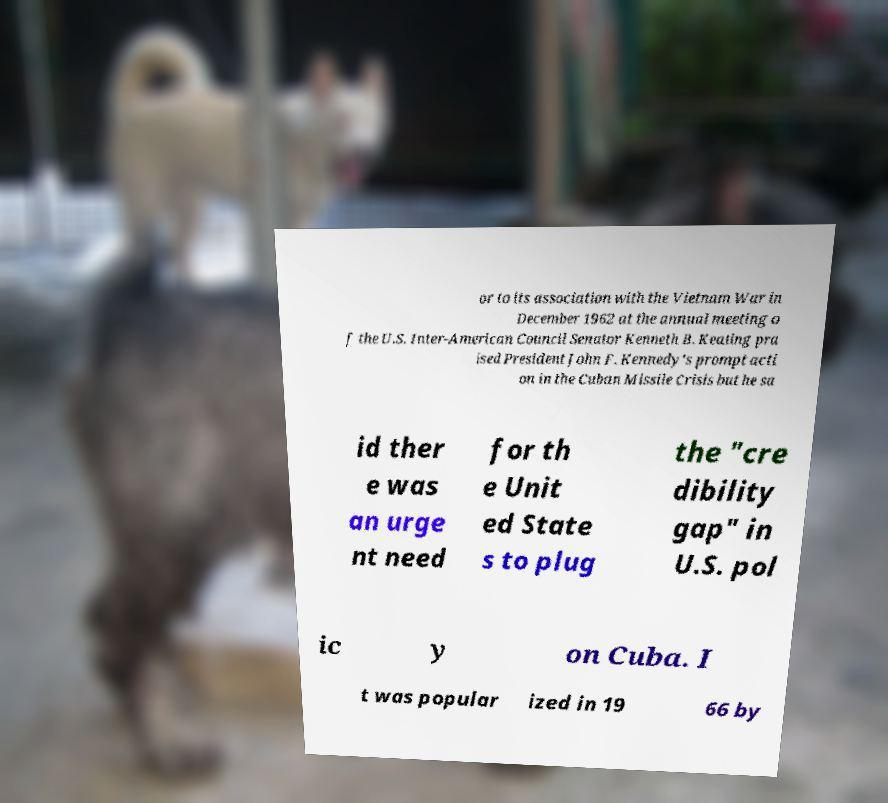Could you extract and type out the text from this image? or to its association with the Vietnam War in December 1962 at the annual meeting o f the U.S. Inter-American Council Senator Kenneth B. Keating pra ised President John F. Kennedy's prompt acti on in the Cuban Missile Crisis but he sa id ther e was an urge nt need for th e Unit ed State s to plug the "cre dibility gap" in U.S. pol ic y on Cuba. I t was popular ized in 19 66 by 